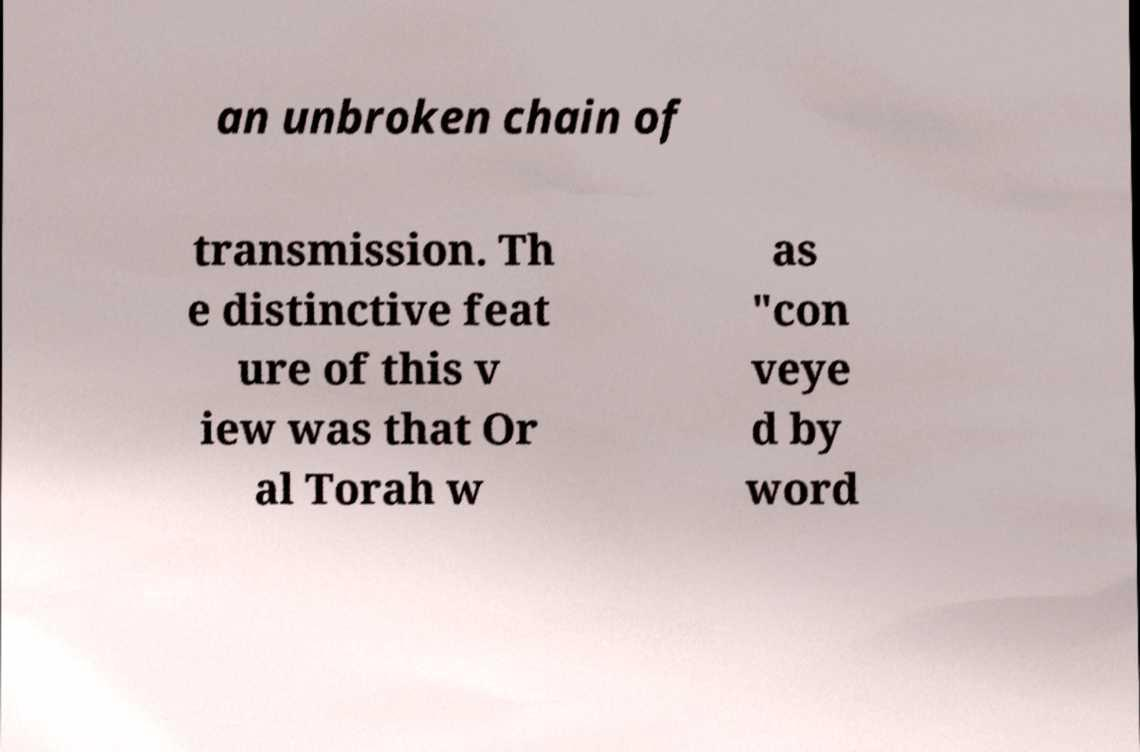Please identify and transcribe the text found in this image. an unbroken chain of transmission. Th e distinctive feat ure of this v iew was that Or al Torah w as "con veye d by word 